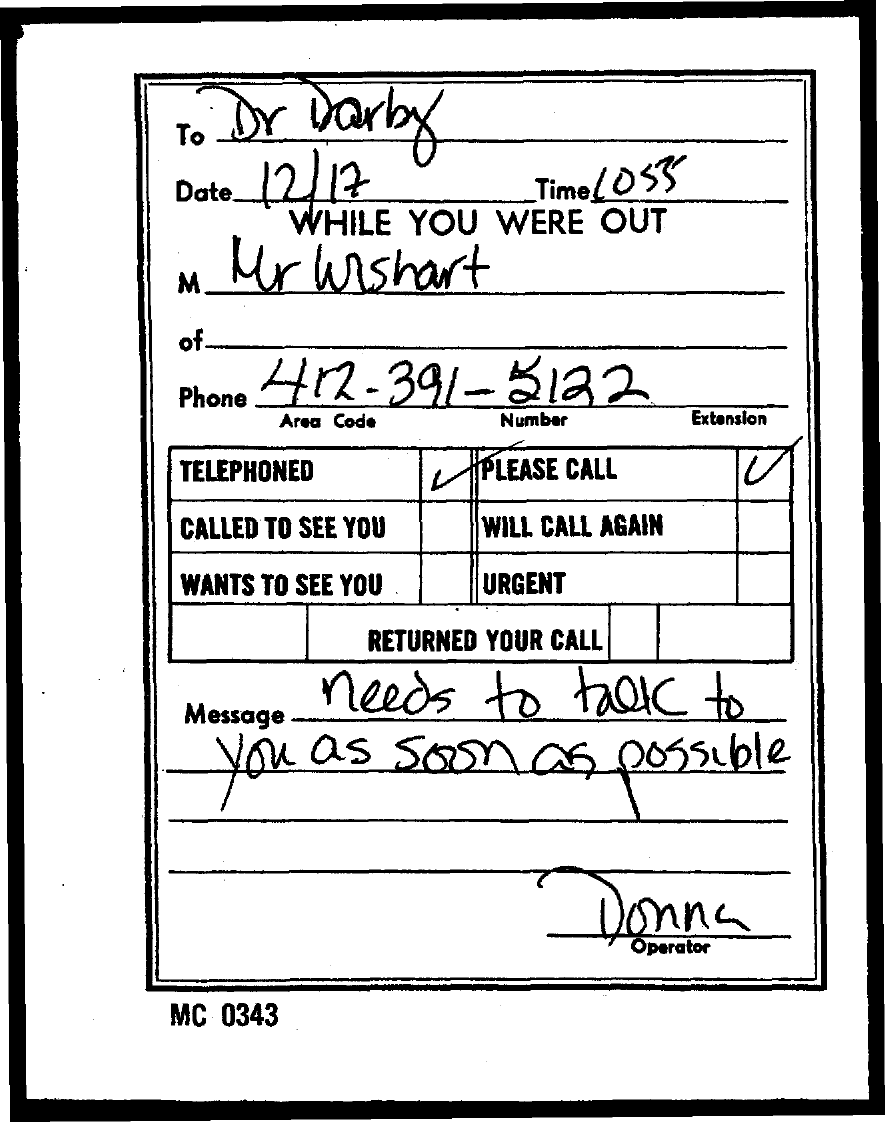What is the date mentioned in the document?
Make the answer very short. 12/17. What is the area code?
Your answer should be compact. 412. Who is the operator?
Provide a succinct answer. Donna. 